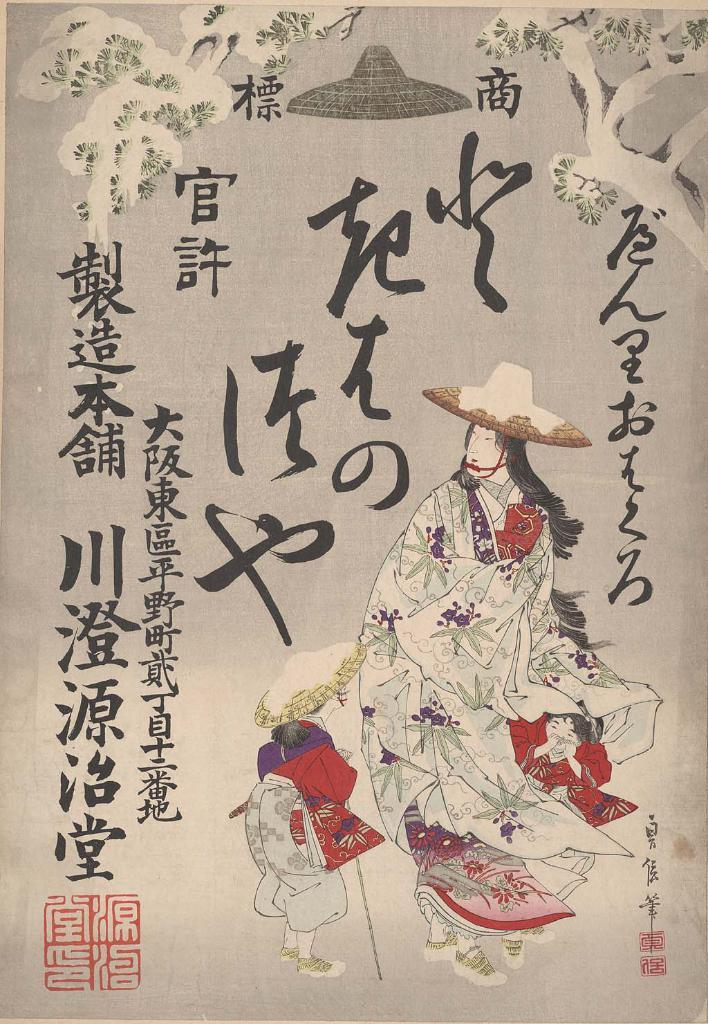What type of visual is depicted in the image? The image is a poster. What can be seen on the poster? There are people with hats and a tree on the poster. Are there any words or letters on the poster? Yes, there are letters on the poster. What month is it in the image? There is no indication of a specific month in the image. How many women are present in the image? The provided facts do not mention the gender of the people on the poster, so we cannot determine the number of women. 